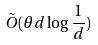Convert formula to latex. <formula><loc_0><loc_0><loc_500><loc_500>\tilde { O } ( \theta d \log \frac { 1 } { d } )</formula> 